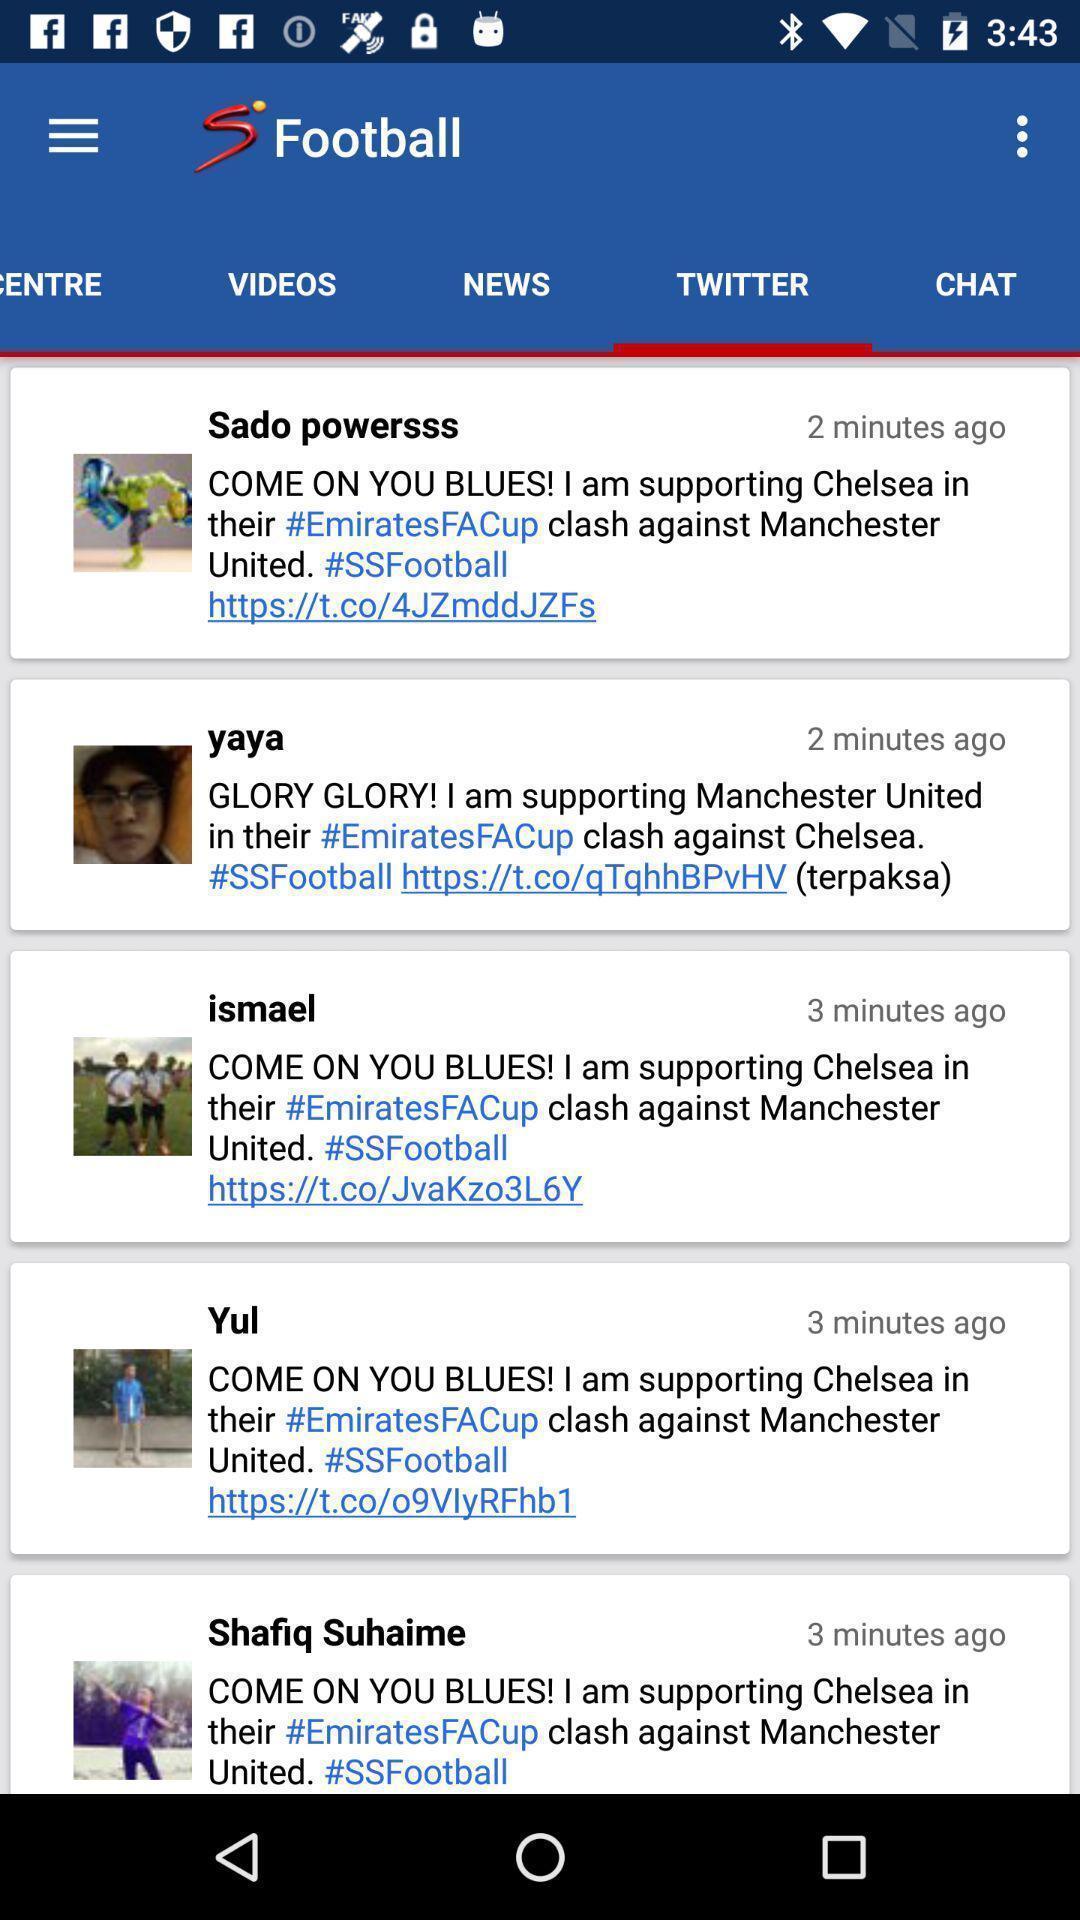Summarize the information in this screenshot. Screen showing twitter page of a gaming app. 